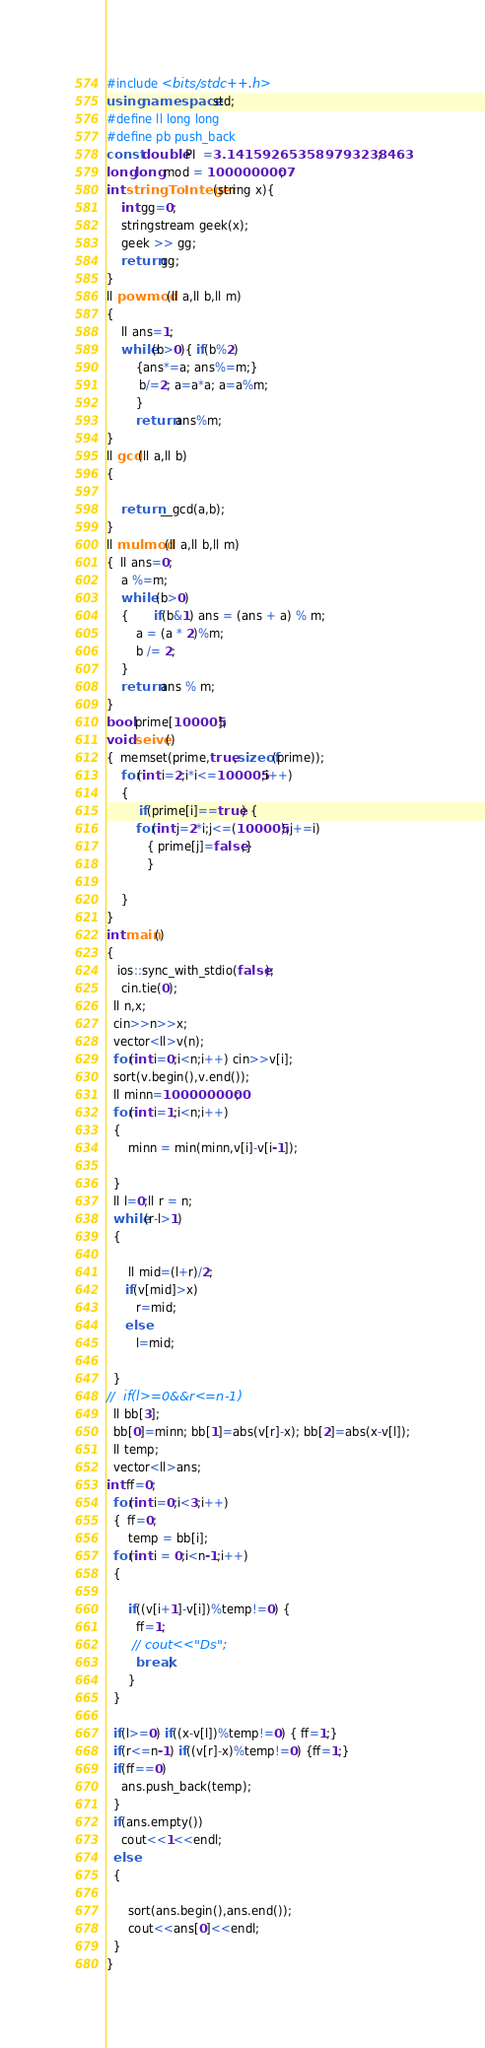<code> <loc_0><loc_0><loc_500><loc_500><_C++_>#include <bits/stdc++.h>
using namespace std;
#define ll long long
#define pb push_back
const double PI  =3.141592653589793238463;
long long mod = 1000000007;
int stringToInteger(string x){
    int gg=0;
    stringstream geek(x);
    geek >> gg;
    return gg;
}
ll powmod(ll a,ll b,ll m)
{
    ll ans=1;
    while(b>0){ if(b%2)
        {ans*=a; ans%=m;}
         b/=2; a=a*a; a=a%m;
        }
        return ans%m;
}
ll gcd(ll a,ll b)
{

    return __gcd(a,b);
}
ll mulmod(ll a,ll b,ll m)
{  ll ans=0;
    a %=m;
    while (b>0)
    {       if(b&1) ans = (ans + a) % m;
        a = (a * 2)%m;
        b /= 2;
    }
    return ans % m;
}
bool prime[100005];
void seive()
{  memset(prime,true,sizeof(prime));
    for(int i=2;i*i<=100005;i++)
    {
         if(prime[i]==true) {
        for(int j=2*i;j<=(100005);j+=i)
           { prime[j]=false;}
           }

    }
}
int main()
{
   ios::sync_with_stdio(false);
	cin.tie(0);
  ll n,x;
  cin>>n>>x;
  vector<ll>v(n);
  for(int i=0;i<n;i++) cin>>v[i];
  sort(v.begin(),v.end());
  ll minn=1000000000;
  for(int i=1;i<n;i++)
  {
      minn = min(minn,v[i]-v[i-1]);

  }
  ll l=0;ll r = n;
  while(r-l>1)
  {

      ll mid=(l+r)/2;
     if(v[mid]>x)
        r=mid;
     else
        l=mid;

  }
//  if(l>=0&&r<=n-1)
  ll bb[3];
  bb[0]=minn; bb[1]=abs(v[r]-x); bb[2]=abs(x-v[l]);
  ll temp;
  vector<ll>ans;
int ff=0;
  for(int i=0;i<3;i++)
  {  ff=0;
      temp = bb[i];
  for(int i = 0;i<n-1;i++)
  {

      if((v[i+1]-v[i])%temp!=0) {
        ff=1;
       // cout<<"Ds";
        break;
      }
  }

  if(l>=0) if((x-v[l])%temp!=0) { ff=1;}
  if(r<=n-1) if((v[r]-x)%temp!=0) {ff=1;}
  if(ff==0)
    ans.push_back(temp);
  }
  if(ans.empty())
    cout<<1<<endl;
  else
  {

      sort(ans.begin(),ans.end());
      cout<<ans[0]<<endl;
  }
}

</code> 